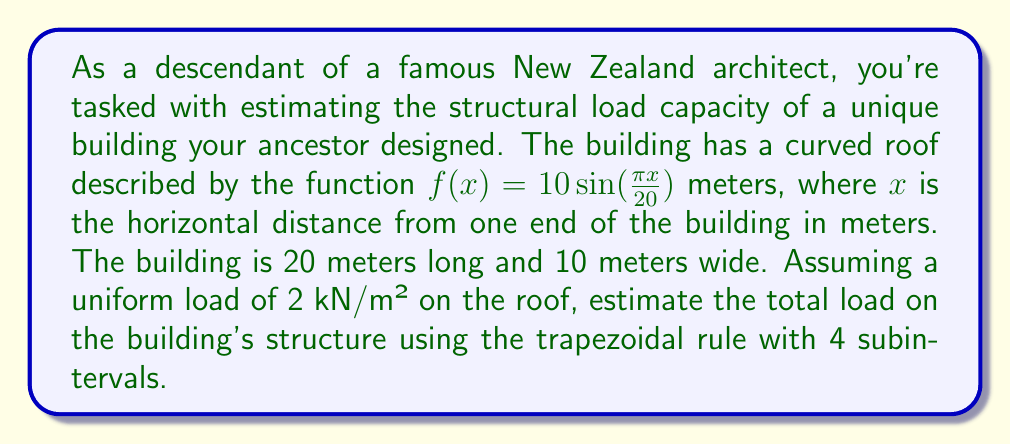Show me your answer to this math problem. To solve this problem, we'll follow these steps:

1) The area of the roof represents the load-bearing surface. We need to find this area using numerical integration.

2) The curve of the roof is given by $f(x) = 10\sin(\frac{\pi x}{20})$ from $x=0$ to $x=20$.

3) To find the arc length of this curve, we use the arc length formula:

   $$L = \int_0^{20} \sqrt{1 + [f'(x)]^2} dx$$

   where $f'(x) = \frac{\pi}{2}\cos(\frac{\pi x}{20})$

4) This integral is difficult to solve analytically, so we'll use the trapezoidal rule with 4 subintervals:

   $$\int_a^b f(x)dx \approx \frac{h}{2}[f(x_0) + 2f(x_1) + 2f(x_2) + 2f(x_3) + f(x_4)]$$

   where $h = \frac{b-a}{n}$, $n$ is the number of subintervals, and $x_i = a + ih$

5) In our case, $a=0$, $b=20$, $n=4$, so $h=5$

6) We need to calculate $\sqrt{1 + [f'(x)]^2}$ at $x = 0, 5, 10, 15, 20$:

   At $x=0$: $\sqrt{1 + (\frac{\pi}{2})^2} \approx 1.8118$
   At $x=5$: $\sqrt{1 + (\frac{\pi}{2}\cos(\frac{\pi}{4}))^2} \approx 1.6583$
   At $x=10$: $\sqrt{1 + (0)^2} = 1$
   At $x=15$: $\sqrt{1 + (\frac{\pi}{2}\cos(\frac{3\pi}{4}))^2} \approx 1.6583$
   At $x=20$: $\sqrt{1 + (\frac{\pi}{2})^2} \approx 1.8118$

7) Applying the trapezoidal rule:

   $$L \approx \frac{5}{2}[1.8118 + 2(1.6583) + 2(1) + 2(1.6583) + 1.8118] = 21.5963$$

8) The roof area is this arc length multiplied by the width:

   Area $= 21.5963 \times 10 = 215.963$ m²

9) The total load is this area multiplied by the uniform load:

   Total load $= 215.963 \times 2 = 431.926$ kN
Answer: The estimated total load on the building's structure is approximately 431.93 kN. 